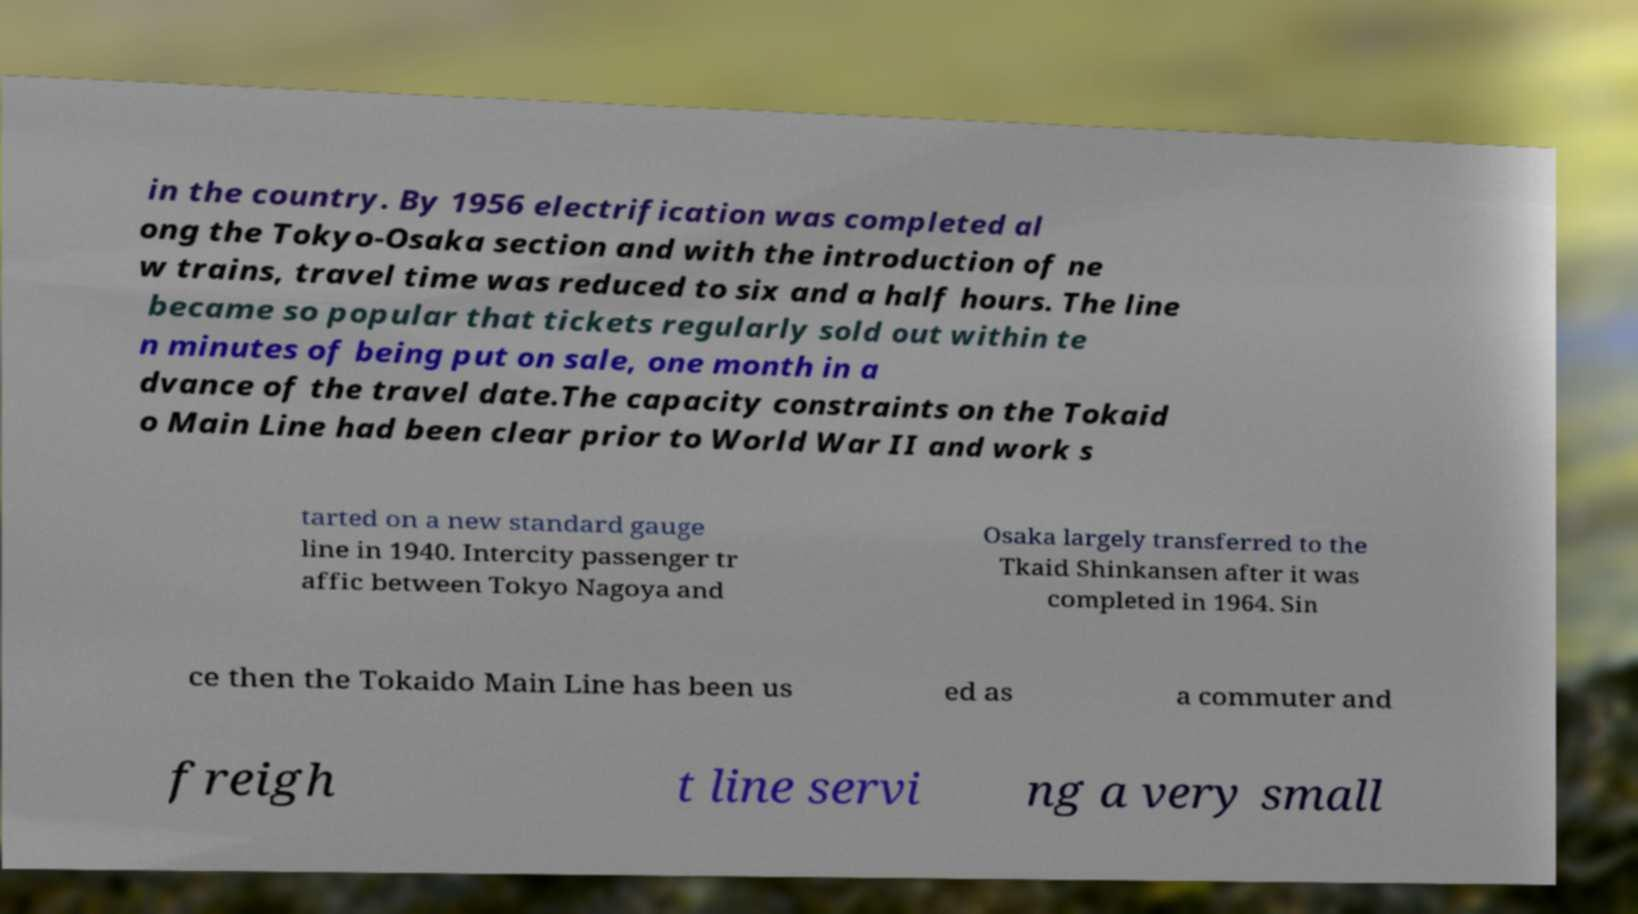Could you assist in decoding the text presented in this image and type it out clearly? in the country. By 1956 electrification was completed al ong the Tokyo-Osaka section and with the introduction of ne w trains, travel time was reduced to six and a half hours. The line became so popular that tickets regularly sold out within te n minutes of being put on sale, one month in a dvance of the travel date.The capacity constraints on the Tokaid o Main Line had been clear prior to World War II and work s tarted on a new standard gauge line in 1940. Intercity passenger tr affic between Tokyo Nagoya and Osaka largely transferred to the Tkaid Shinkansen after it was completed in 1964. Sin ce then the Tokaido Main Line has been us ed as a commuter and freigh t line servi ng a very small 